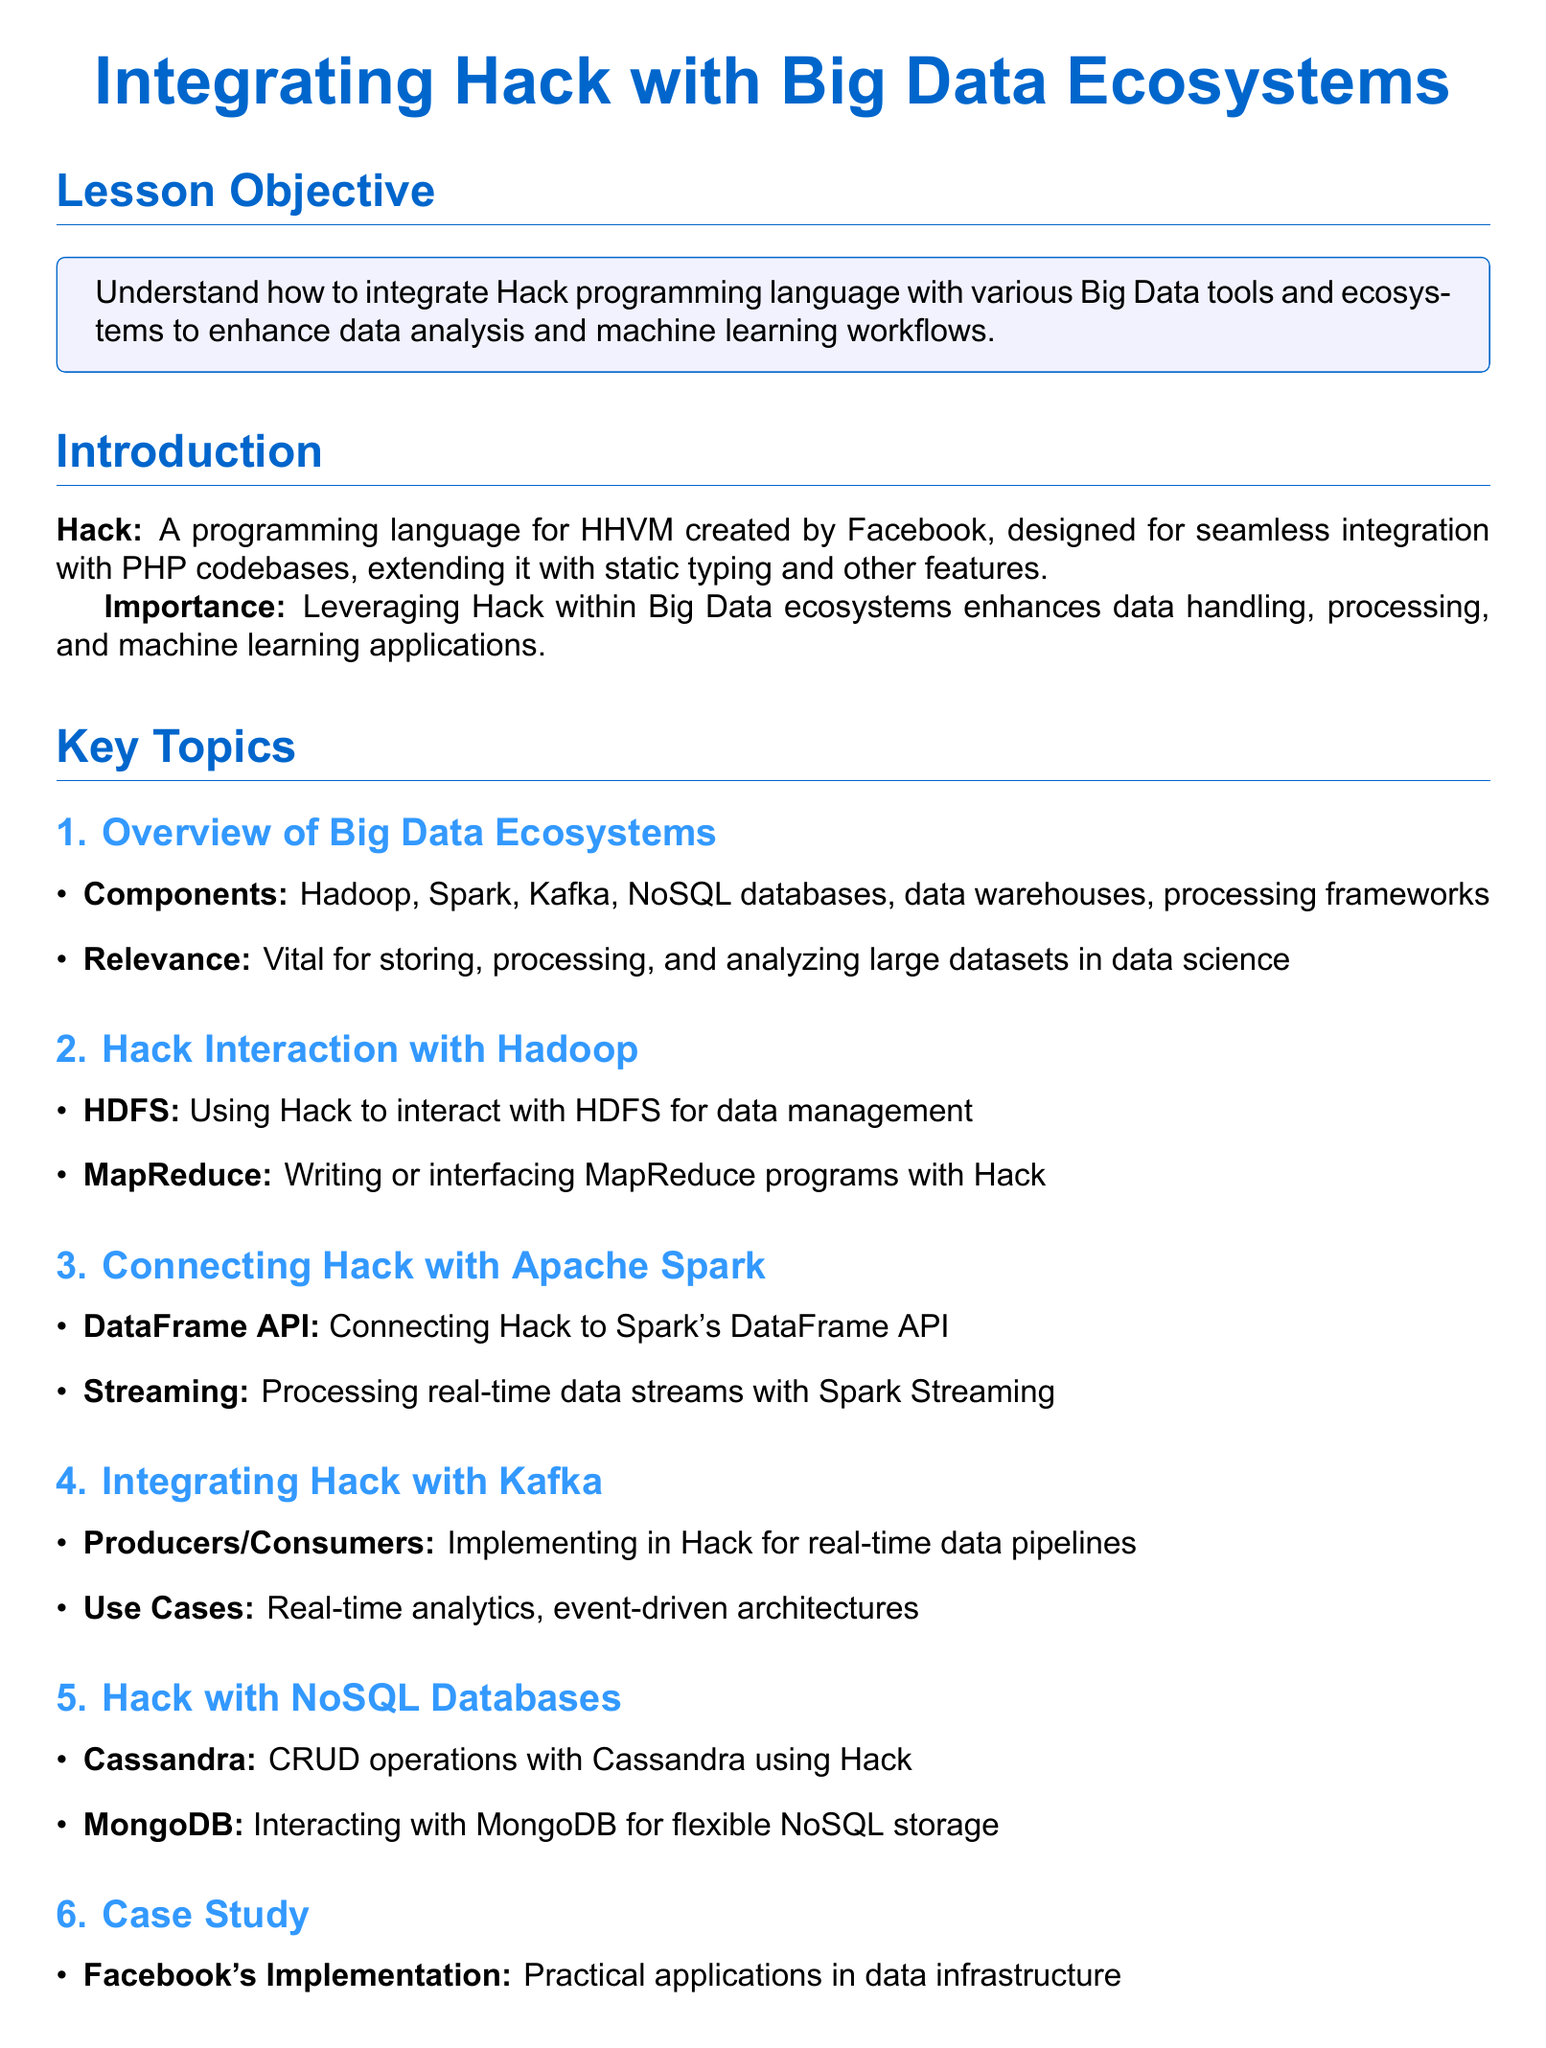What is the objective of the lesson? The lesson objective is stated at the top section of the document, focusing on understanding Hack integration with Big Data tools.
Answer: Understand how to integrate Hack programming language with various Big Data tools and ecosystems to enhance data analysis and machine learning workflows What programming language is being discussed? The introduction mentions Hack as the programming language created by Facebook for HHVM.
Answer: Hack Which ecosystem component is specifically mentioned for data management with Hack? The section on Hack interaction with Hadoop highlights HDFS for data management purposes.
Answer: HDFS What is a use case of integrating Hack with Kafka? The document specifies real-time analytics as a use case for Hack integration with Kafka.
Answer: Real-time analytics What two NoSQL databases are discussed in the document? The section on Hack with NoSQL databases lists Cassandra and MongoDB as examples.
Answer: Cassandra and MongoDB What is one key takeaway from the conclusion? The conclusion summarizes practical knowledge for data analysis and machine learning tasks as a takeaway.
Answer: Practical knowledge for data analysis and machine learning tasks 